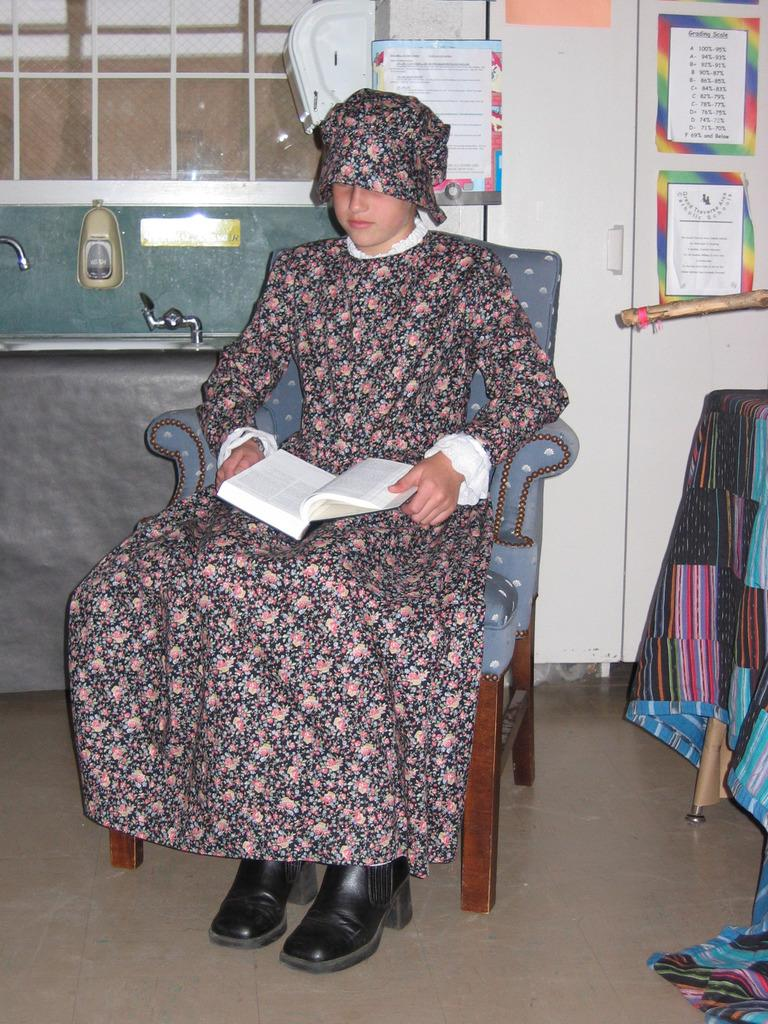Who is the main subject in the image? There is a girl in the image. What is the girl doing in the image? The girl is sitting on a chair. What is the girl holding in the image? The girl is holding a book. What can be seen in the background of the image? There are papers visible in the background of the image. What type of boats can be seen in the image? There are no boats present in the image. What color are the girl's trousers in the image? The girl is not wearing trousers in the image; she is wearing a dress. 